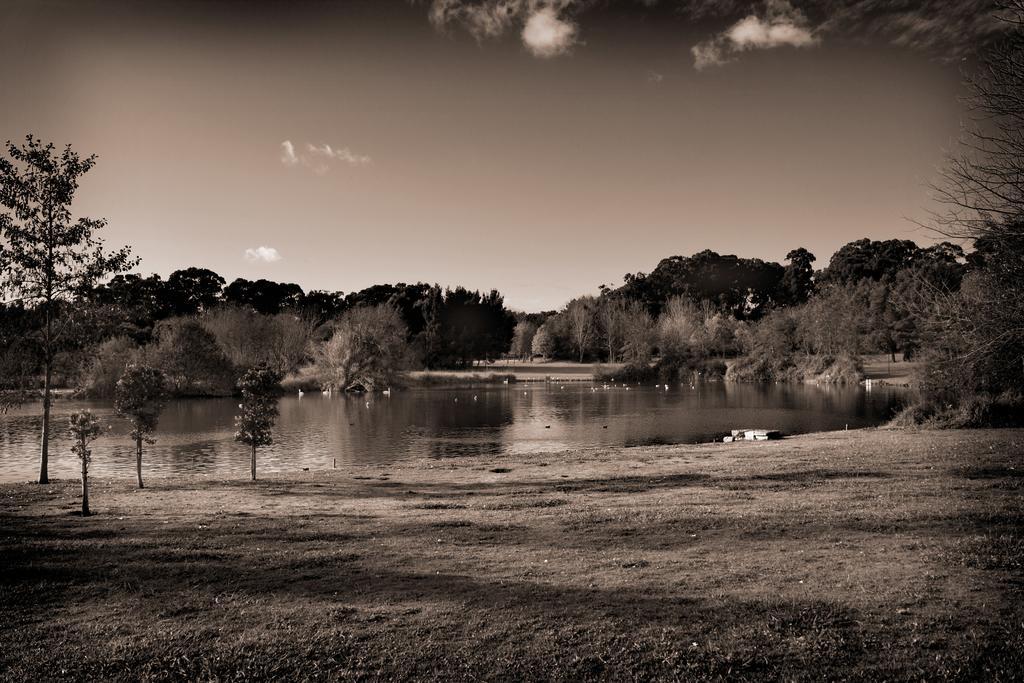Please provide a concise description of this image. This is a black and white image, where we can see trees, lake, ground, sky and the cloud. 